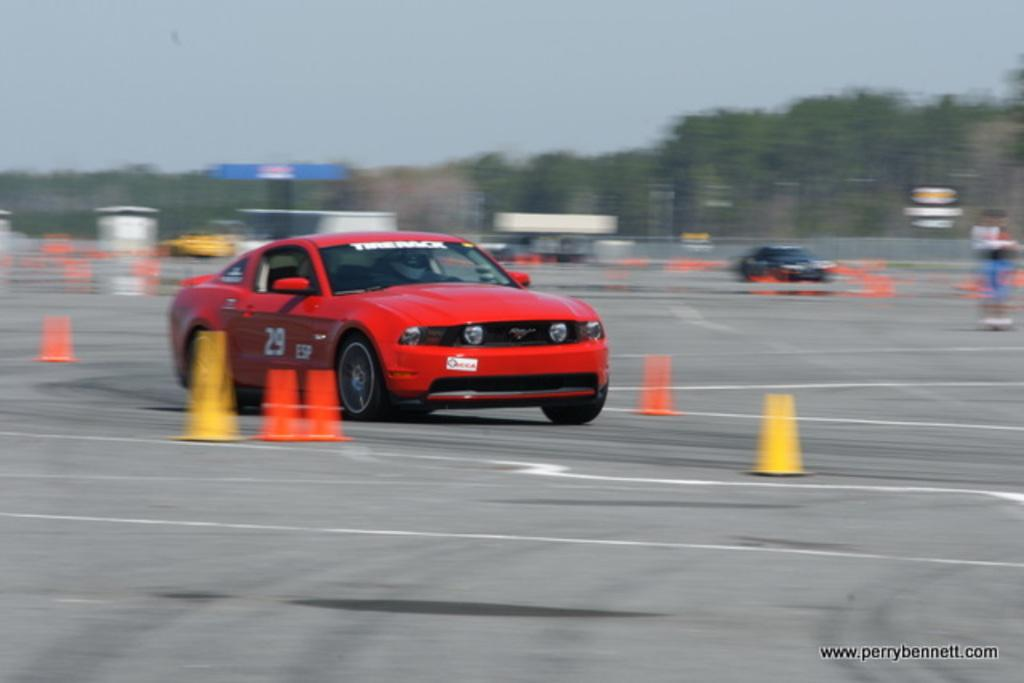What can be seen on the road in the image? There are cars on the road in the image. What objects are beside the cars? There are traffic cone cups beside the cars. What type of natural scenery is visible in the background of the image? There are trees in the background of the image. What part of the natural environment is visible in the image? The sky is visible in the background of the image. What type of cover is protecting the cars from the slope in the image? There is no cover or slope present in the image; it features cars on a road with traffic cone cups beside them. 